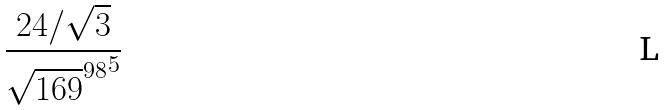Convert formula to latex. <formula><loc_0><loc_0><loc_500><loc_500>\frac { 2 4 / \sqrt { 3 } } { { \sqrt { 1 6 9 } ^ { 9 8 } } ^ { 5 } }</formula> 